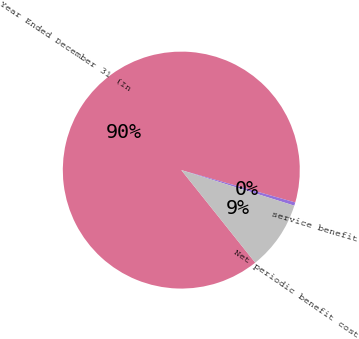Convert chart to OTSL. <chart><loc_0><loc_0><loc_500><loc_500><pie_chart><fcel>Year Ended December 31 (In<fcel>service benefit<fcel>Net periodic benefit cost<nl><fcel>90.14%<fcel>0.45%<fcel>9.42%<nl></chart> 